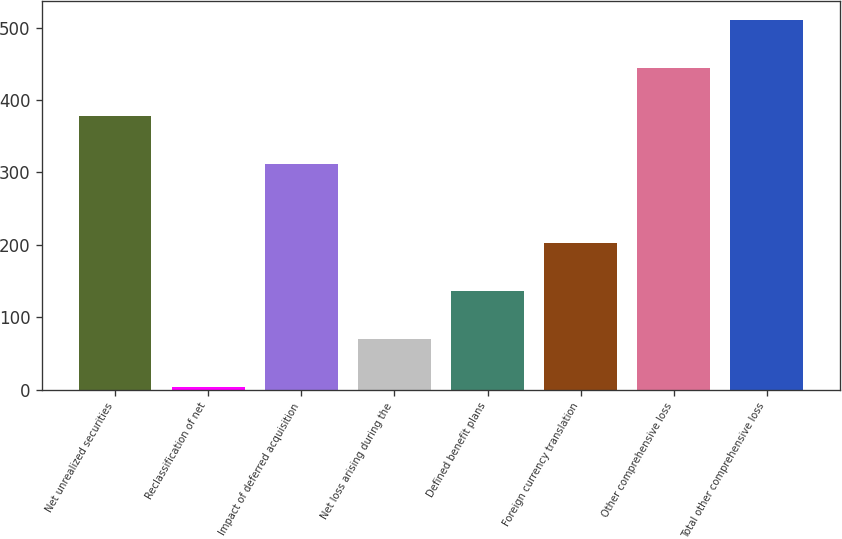Convert chart. <chart><loc_0><loc_0><loc_500><loc_500><bar_chart><fcel>Net unrealized securities<fcel>Reclassification of net<fcel>Impact of deferred acquisition<fcel>Net loss arising during the<fcel>Defined benefit plans<fcel>Foreign currency translation<fcel>Other comprehensive loss<fcel>Total other comprehensive loss<nl><fcel>378.4<fcel>4<fcel>312<fcel>70.4<fcel>136.8<fcel>203.2<fcel>444.8<fcel>511.2<nl></chart> 